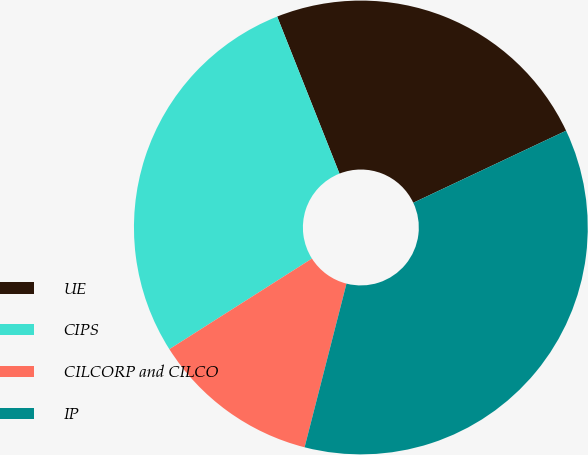<chart> <loc_0><loc_0><loc_500><loc_500><pie_chart><fcel>UE<fcel>CIPS<fcel>CILCORP and CILCO<fcel>IP<nl><fcel>24.0%<fcel>28.0%<fcel>12.0%<fcel>36.0%<nl></chart> 